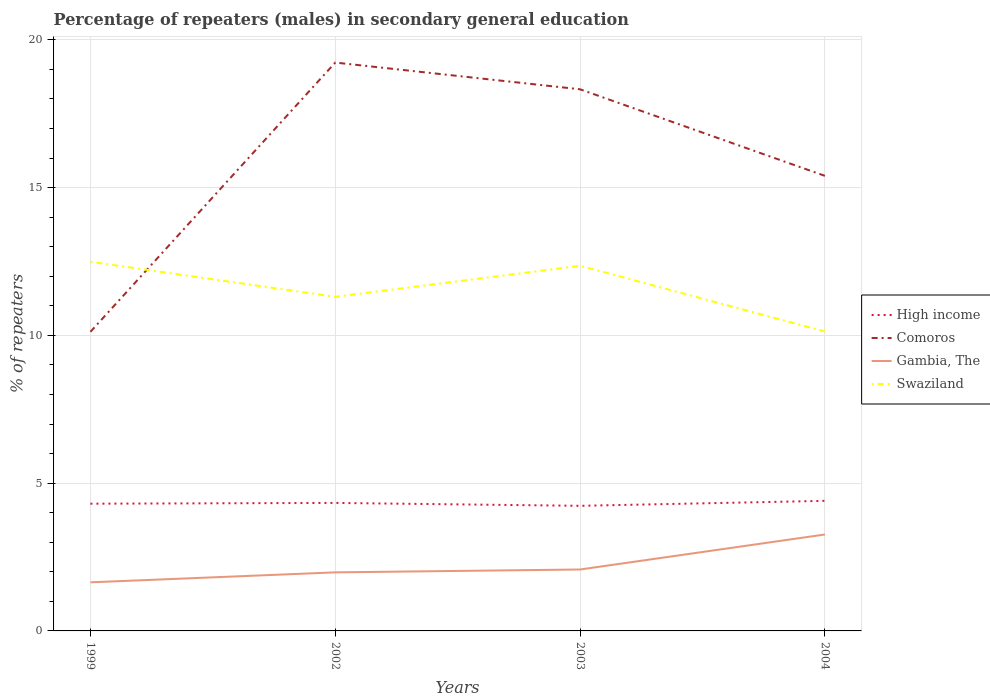Is the number of lines equal to the number of legend labels?
Your response must be concise. Yes. Across all years, what is the maximum percentage of male repeaters in Comoros?
Provide a succinct answer. 10.12. What is the total percentage of male repeaters in High income in the graph?
Give a very brief answer. 0.07. What is the difference between the highest and the second highest percentage of male repeaters in Gambia, The?
Your response must be concise. 1.62. What is the difference between the highest and the lowest percentage of male repeaters in High income?
Give a very brief answer. 2. How many lines are there?
Your answer should be very brief. 4. What is the difference between two consecutive major ticks on the Y-axis?
Your answer should be compact. 5. Are the values on the major ticks of Y-axis written in scientific E-notation?
Your answer should be compact. No. Does the graph contain any zero values?
Your answer should be very brief. No. Does the graph contain grids?
Make the answer very short. Yes. How many legend labels are there?
Your response must be concise. 4. What is the title of the graph?
Provide a short and direct response. Percentage of repeaters (males) in secondary general education. What is the label or title of the X-axis?
Offer a terse response. Years. What is the label or title of the Y-axis?
Your answer should be compact. % of repeaters. What is the % of repeaters in High income in 1999?
Your response must be concise. 4.31. What is the % of repeaters of Comoros in 1999?
Ensure brevity in your answer.  10.12. What is the % of repeaters of Gambia, The in 1999?
Offer a very short reply. 1.64. What is the % of repeaters in Swaziland in 1999?
Give a very brief answer. 12.49. What is the % of repeaters in High income in 2002?
Provide a succinct answer. 4.33. What is the % of repeaters of Comoros in 2002?
Your answer should be very brief. 19.23. What is the % of repeaters in Gambia, The in 2002?
Ensure brevity in your answer.  1.98. What is the % of repeaters in Swaziland in 2002?
Keep it short and to the point. 11.31. What is the % of repeaters of High income in 2003?
Keep it short and to the point. 4.23. What is the % of repeaters in Comoros in 2003?
Provide a short and direct response. 18.33. What is the % of repeaters in Gambia, The in 2003?
Ensure brevity in your answer.  2.08. What is the % of repeaters of Swaziland in 2003?
Give a very brief answer. 12.36. What is the % of repeaters of High income in 2004?
Your answer should be very brief. 4.4. What is the % of repeaters of Comoros in 2004?
Offer a terse response. 15.4. What is the % of repeaters in Gambia, The in 2004?
Offer a very short reply. 3.26. What is the % of repeaters in Swaziland in 2004?
Your answer should be compact. 10.13. Across all years, what is the maximum % of repeaters of High income?
Your answer should be very brief. 4.4. Across all years, what is the maximum % of repeaters of Comoros?
Your answer should be compact. 19.23. Across all years, what is the maximum % of repeaters of Gambia, The?
Offer a terse response. 3.26. Across all years, what is the maximum % of repeaters in Swaziland?
Make the answer very short. 12.49. Across all years, what is the minimum % of repeaters in High income?
Make the answer very short. 4.23. Across all years, what is the minimum % of repeaters in Comoros?
Ensure brevity in your answer.  10.12. Across all years, what is the minimum % of repeaters in Gambia, The?
Keep it short and to the point. 1.64. Across all years, what is the minimum % of repeaters in Swaziland?
Ensure brevity in your answer.  10.13. What is the total % of repeaters of High income in the graph?
Keep it short and to the point. 17.27. What is the total % of repeaters in Comoros in the graph?
Make the answer very short. 63.08. What is the total % of repeaters of Gambia, The in the graph?
Provide a short and direct response. 8.97. What is the total % of repeaters in Swaziland in the graph?
Offer a terse response. 46.29. What is the difference between the % of repeaters in High income in 1999 and that in 2002?
Provide a short and direct response. -0.03. What is the difference between the % of repeaters of Comoros in 1999 and that in 2002?
Make the answer very short. -9.11. What is the difference between the % of repeaters of Gambia, The in 1999 and that in 2002?
Your response must be concise. -0.34. What is the difference between the % of repeaters of Swaziland in 1999 and that in 2002?
Your answer should be very brief. 1.18. What is the difference between the % of repeaters in High income in 1999 and that in 2003?
Your answer should be very brief. 0.07. What is the difference between the % of repeaters in Comoros in 1999 and that in 2003?
Your response must be concise. -8.21. What is the difference between the % of repeaters in Gambia, The in 1999 and that in 2003?
Give a very brief answer. -0.43. What is the difference between the % of repeaters of Swaziland in 1999 and that in 2003?
Provide a succinct answer. 0.14. What is the difference between the % of repeaters of High income in 1999 and that in 2004?
Ensure brevity in your answer.  -0.1. What is the difference between the % of repeaters of Comoros in 1999 and that in 2004?
Keep it short and to the point. -5.28. What is the difference between the % of repeaters of Gambia, The in 1999 and that in 2004?
Your response must be concise. -1.62. What is the difference between the % of repeaters of Swaziland in 1999 and that in 2004?
Make the answer very short. 2.36. What is the difference between the % of repeaters in High income in 2002 and that in 2003?
Ensure brevity in your answer.  0.1. What is the difference between the % of repeaters in Comoros in 2002 and that in 2003?
Make the answer very short. 0.9. What is the difference between the % of repeaters of Gambia, The in 2002 and that in 2003?
Keep it short and to the point. -0.1. What is the difference between the % of repeaters in Swaziland in 2002 and that in 2003?
Offer a terse response. -1.05. What is the difference between the % of repeaters in High income in 2002 and that in 2004?
Your response must be concise. -0.07. What is the difference between the % of repeaters in Comoros in 2002 and that in 2004?
Keep it short and to the point. 3.83. What is the difference between the % of repeaters of Gambia, The in 2002 and that in 2004?
Provide a succinct answer. -1.28. What is the difference between the % of repeaters of Swaziland in 2002 and that in 2004?
Your answer should be very brief. 1.17. What is the difference between the % of repeaters of High income in 2003 and that in 2004?
Keep it short and to the point. -0.17. What is the difference between the % of repeaters of Comoros in 2003 and that in 2004?
Give a very brief answer. 2.93. What is the difference between the % of repeaters in Gambia, The in 2003 and that in 2004?
Keep it short and to the point. -1.18. What is the difference between the % of repeaters of Swaziland in 2003 and that in 2004?
Give a very brief answer. 2.22. What is the difference between the % of repeaters in High income in 1999 and the % of repeaters in Comoros in 2002?
Make the answer very short. -14.93. What is the difference between the % of repeaters of High income in 1999 and the % of repeaters of Gambia, The in 2002?
Provide a succinct answer. 2.32. What is the difference between the % of repeaters in High income in 1999 and the % of repeaters in Swaziland in 2002?
Provide a short and direct response. -7. What is the difference between the % of repeaters of Comoros in 1999 and the % of repeaters of Gambia, The in 2002?
Keep it short and to the point. 8.14. What is the difference between the % of repeaters in Comoros in 1999 and the % of repeaters in Swaziland in 2002?
Ensure brevity in your answer.  -1.19. What is the difference between the % of repeaters in Gambia, The in 1999 and the % of repeaters in Swaziland in 2002?
Your response must be concise. -9.66. What is the difference between the % of repeaters of High income in 1999 and the % of repeaters of Comoros in 2003?
Provide a short and direct response. -14.02. What is the difference between the % of repeaters of High income in 1999 and the % of repeaters of Gambia, The in 2003?
Keep it short and to the point. 2.23. What is the difference between the % of repeaters in High income in 1999 and the % of repeaters in Swaziland in 2003?
Make the answer very short. -8.05. What is the difference between the % of repeaters in Comoros in 1999 and the % of repeaters in Gambia, The in 2003?
Ensure brevity in your answer.  8.04. What is the difference between the % of repeaters of Comoros in 1999 and the % of repeaters of Swaziland in 2003?
Your answer should be very brief. -2.23. What is the difference between the % of repeaters in Gambia, The in 1999 and the % of repeaters in Swaziland in 2003?
Your answer should be very brief. -10.71. What is the difference between the % of repeaters in High income in 1999 and the % of repeaters in Comoros in 2004?
Offer a very short reply. -11.09. What is the difference between the % of repeaters of High income in 1999 and the % of repeaters of Gambia, The in 2004?
Your answer should be very brief. 1.04. What is the difference between the % of repeaters of High income in 1999 and the % of repeaters of Swaziland in 2004?
Make the answer very short. -5.83. What is the difference between the % of repeaters of Comoros in 1999 and the % of repeaters of Gambia, The in 2004?
Provide a short and direct response. 6.86. What is the difference between the % of repeaters of Comoros in 1999 and the % of repeaters of Swaziland in 2004?
Your response must be concise. -0.01. What is the difference between the % of repeaters of Gambia, The in 1999 and the % of repeaters of Swaziland in 2004?
Offer a very short reply. -8.49. What is the difference between the % of repeaters in High income in 2002 and the % of repeaters in Comoros in 2003?
Your response must be concise. -14. What is the difference between the % of repeaters in High income in 2002 and the % of repeaters in Gambia, The in 2003?
Offer a very short reply. 2.25. What is the difference between the % of repeaters in High income in 2002 and the % of repeaters in Swaziland in 2003?
Your answer should be very brief. -8.02. What is the difference between the % of repeaters in Comoros in 2002 and the % of repeaters in Gambia, The in 2003?
Make the answer very short. 17.15. What is the difference between the % of repeaters of Comoros in 2002 and the % of repeaters of Swaziland in 2003?
Give a very brief answer. 6.88. What is the difference between the % of repeaters of Gambia, The in 2002 and the % of repeaters of Swaziland in 2003?
Keep it short and to the point. -10.37. What is the difference between the % of repeaters of High income in 2002 and the % of repeaters of Comoros in 2004?
Ensure brevity in your answer.  -11.07. What is the difference between the % of repeaters in High income in 2002 and the % of repeaters in Gambia, The in 2004?
Give a very brief answer. 1.07. What is the difference between the % of repeaters in High income in 2002 and the % of repeaters in Swaziland in 2004?
Keep it short and to the point. -5.8. What is the difference between the % of repeaters in Comoros in 2002 and the % of repeaters in Gambia, The in 2004?
Keep it short and to the point. 15.97. What is the difference between the % of repeaters of Comoros in 2002 and the % of repeaters of Swaziland in 2004?
Give a very brief answer. 9.1. What is the difference between the % of repeaters of Gambia, The in 2002 and the % of repeaters of Swaziland in 2004?
Your response must be concise. -8.15. What is the difference between the % of repeaters in High income in 2003 and the % of repeaters in Comoros in 2004?
Offer a terse response. -11.17. What is the difference between the % of repeaters of High income in 2003 and the % of repeaters of Gambia, The in 2004?
Offer a terse response. 0.97. What is the difference between the % of repeaters in High income in 2003 and the % of repeaters in Swaziland in 2004?
Offer a terse response. -5.9. What is the difference between the % of repeaters in Comoros in 2003 and the % of repeaters in Gambia, The in 2004?
Make the answer very short. 15.06. What is the difference between the % of repeaters in Comoros in 2003 and the % of repeaters in Swaziland in 2004?
Your answer should be very brief. 8.19. What is the difference between the % of repeaters of Gambia, The in 2003 and the % of repeaters of Swaziland in 2004?
Your answer should be very brief. -8.05. What is the average % of repeaters in High income per year?
Offer a very short reply. 4.32. What is the average % of repeaters in Comoros per year?
Ensure brevity in your answer.  15.77. What is the average % of repeaters in Gambia, The per year?
Your response must be concise. 2.24. What is the average % of repeaters of Swaziland per year?
Your response must be concise. 11.57. In the year 1999, what is the difference between the % of repeaters in High income and % of repeaters in Comoros?
Ensure brevity in your answer.  -5.82. In the year 1999, what is the difference between the % of repeaters in High income and % of repeaters in Gambia, The?
Offer a very short reply. 2.66. In the year 1999, what is the difference between the % of repeaters of High income and % of repeaters of Swaziland?
Give a very brief answer. -8.19. In the year 1999, what is the difference between the % of repeaters in Comoros and % of repeaters in Gambia, The?
Your answer should be very brief. 8.48. In the year 1999, what is the difference between the % of repeaters in Comoros and % of repeaters in Swaziland?
Make the answer very short. -2.37. In the year 1999, what is the difference between the % of repeaters of Gambia, The and % of repeaters of Swaziland?
Your answer should be compact. -10.85. In the year 2002, what is the difference between the % of repeaters in High income and % of repeaters in Comoros?
Provide a succinct answer. -14.9. In the year 2002, what is the difference between the % of repeaters in High income and % of repeaters in Gambia, The?
Provide a short and direct response. 2.35. In the year 2002, what is the difference between the % of repeaters of High income and % of repeaters of Swaziland?
Provide a succinct answer. -6.98. In the year 2002, what is the difference between the % of repeaters in Comoros and % of repeaters in Gambia, The?
Give a very brief answer. 17.25. In the year 2002, what is the difference between the % of repeaters in Comoros and % of repeaters in Swaziland?
Provide a succinct answer. 7.93. In the year 2002, what is the difference between the % of repeaters of Gambia, The and % of repeaters of Swaziland?
Your answer should be very brief. -9.33. In the year 2003, what is the difference between the % of repeaters of High income and % of repeaters of Comoros?
Your response must be concise. -14.09. In the year 2003, what is the difference between the % of repeaters in High income and % of repeaters in Gambia, The?
Your answer should be very brief. 2.15. In the year 2003, what is the difference between the % of repeaters in High income and % of repeaters in Swaziland?
Your answer should be compact. -8.12. In the year 2003, what is the difference between the % of repeaters in Comoros and % of repeaters in Gambia, The?
Provide a short and direct response. 16.25. In the year 2003, what is the difference between the % of repeaters of Comoros and % of repeaters of Swaziland?
Offer a terse response. 5.97. In the year 2003, what is the difference between the % of repeaters in Gambia, The and % of repeaters in Swaziland?
Give a very brief answer. -10.28. In the year 2004, what is the difference between the % of repeaters in High income and % of repeaters in Comoros?
Keep it short and to the point. -11. In the year 2004, what is the difference between the % of repeaters in High income and % of repeaters in Gambia, The?
Offer a very short reply. 1.14. In the year 2004, what is the difference between the % of repeaters in High income and % of repeaters in Swaziland?
Your answer should be very brief. -5.73. In the year 2004, what is the difference between the % of repeaters of Comoros and % of repeaters of Gambia, The?
Your response must be concise. 12.14. In the year 2004, what is the difference between the % of repeaters in Comoros and % of repeaters in Swaziland?
Make the answer very short. 5.27. In the year 2004, what is the difference between the % of repeaters of Gambia, The and % of repeaters of Swaziland?
Offer a very short reply. -6.87. What is the ratio of the % of repeaters in Comoros in 1999 to that in 2002?
Your answer should be very brief. 0.53. What is the ratio of the % of repeaters of Gambia, The in 1999 to that in 2002?
Ensure brevity in your answer.  0.83. What is the ratio of the % of repeaters in Swaziland in 1999 to that in 2002?
Your response must be concise. 1.1. What is the ratio of the % of repeaters of High income in 1999 to that in 2003?
Give a very brief answer. 1.02. What is the ratio of the % of repeaters of Comoros in 1999 to that in 2003?
Provide a succinct answer. 0.55. What is the ratio of the % of repeaters of Gambia, The in 1999 to that in 2003?
Your answer should be compact. 0.79. What is the ratio of the % of repeaters in Swaziland in 1999 to that in 2003?
Provide a short and direct response. 1.01. What is the ratio of the % of repeaters of High income in 1999 to that in 2004?
Offer a terse response. 0.98. What is the ratio of the % of repeaters in Comoros in 1999 to that in 2004?
Your response must be concise. 0.66. What is the ratio of the % of repeaters in Gambia, The in 1999 to that in 2004?
Provide a short and direct response. 0.5. What is the ratio of the % of repeaters in Swaziland in 1999 to that in 2004?
Your answer should be very brief. 1.23. What is the ratio of the % of repeaters in High income in 2002 to that in 2003?
Give a very brief answer. 1.02. What is the ratio of the % of repeaters of Comoros in 2002 to that in 2003?
Keep it short and to the point. 1.05. What is the ratio of the % of repeaters of Gambia, The in 2002 to that in 2003?
Your answer should be very brief. 0.95. What is the ratio of the % of repeaters of Swaziland in 2002 to that in 2003?
Your response must be concise. 0.92. What is the ratio of the % of repeaters of High income in 2002 to that in 2004?
Give a very brief answer. 0.98. What is the ratio of the % of repeaters in Comoros in 2002 to that in 2004?
Make the answer very short. 1.25. What is the ratio of the % of repeaters of Gambia, The in 2002 to that in 2004?
Your answer should be compact. 0.61. What is the ratio of the % of repeaters of Swaziland in 2002 to that in 2004?
Your response must be concise. 1.12. What is the ratio of the % of repeaters of High income in 2003 to that in 2004?
Give a very brief answer. 0.96. What is the ratio of the % of repeaters of Comoros in 2003 to that in 2004?
Keep it short and to the point. 1.19. What is the ratio of the % of repeaters in Gambia, The in 2003 to that in 2004?
Your answer should be compact. 0.64. What is the ratio of the % of repeaters in Swaziland in 2003 to that in 2004?
Make the answer very short. 1.22. What is the difference between the highest and the second highest % of repeaters of High income?
Give a very brief answer. 0.07. What is the difference between the highest and the second highest % of repeaters in Comoros?
Offer a very short reply. 0.9. What is the difference between the highest and the second highest % of repeaters of Gambia, The?
Keep it short and to the point. 1.18. What is the difference between the highest and the second highest % of repeaters in Swaziland?
Offer a terse response. 0.14. What is the difference between the highest and the lowest % of repeaters of High income?
Provide a short and direct response. 0.17. What is the difference between the highest and the lowest % of repeaters of Comoros?
Make the answer very short. 9.11. What is the difference between the highest and the lowest % of repeaters in Gambia, The?
Provide a succinct answer. 1.62. What is the difference between the highest and the lowest % of repeaters of Swaziland?
Give a very brief answer. 2.36. 